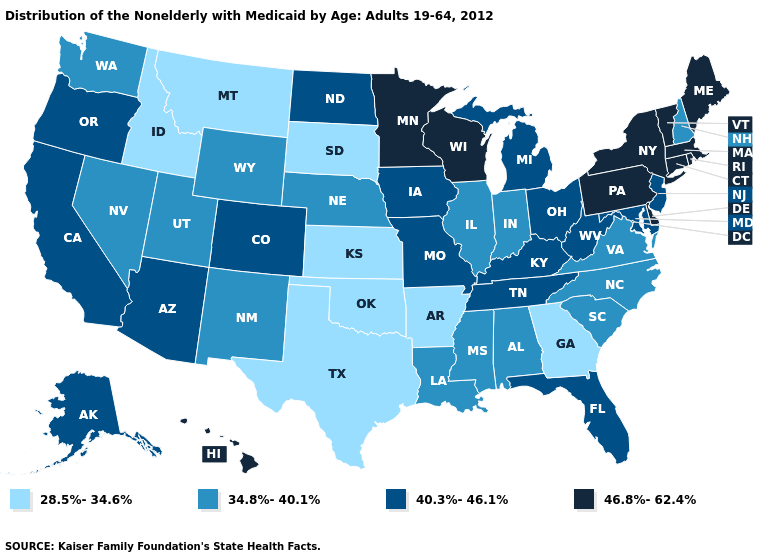How many symbols are there in the legend?
Answer briefly. 4. What is the value of Arkansas?
Write a very short answer. 28.5%-34.6%. What is the highest value in states that border Indiana?
Answer briefly. 40.3%-46.1%. Name the states that have a value in the range 34.8%-40.1%?
Give a very brief answer. Alabama, Illinois, Indiana, Louisiana, Mississippi, Nebraska, Nevada, New Hampshire, New Mexico, North Carolina, South Carolina, Utah, Virginia, Washington, Wyoming. Name the states that have a value in the range 40.3%-46.1%?
Be succinct. Alaska, Arizona, California, Colorado, Florida, Iowa, Kentucky, Maryland, Michigan, Missouri, New Jersey, North Dakota, Ohio, Oregon, Tennessee, West Virginia. What is the value of Maryland?
Concise answer only. 40.3%-46.1%. Name the states that have a value in the range 46.8%-62.4%?
Quick response, please. Connecticut, Delaware, Hawaii, Maine, Massachusetts, Minnesota, New York, Pennsylvania, Rhode Island, Vermont, Wisconsin. Does the first symbol in the legend represent the smallest category?
Give a very brief answer. Yes. Which states have the highest value in the USA?
Answer briefly. Connecticut, Delaware, Hawaii, Maine, Massachusetts, Minnesota, New York, Pennsylvania, Rhode Island, Vermont, Wisconsin. What is the highest value in states that border West Virginia?
Short answer required. 46.8%-62.4%. Name the states that have a value in the range 28.5%-34.6%?
Answer briefly. Arkansas, Georgia, Idaho, Kansas, Montana, Oklahoma, South Dakota, Texas. Does New Hampshire have the highest value in the Northeast?
Give a very brief answer. No. What is the lowest value in the MidWest?
Give a very brief answer. 28.5%-34.6%. Among the states that border Kentucky , which have the lowest value?
Concise answer only. Illinois, Indiana, Virginia. What is the value of Michigan?
Answer briefly. 40.3%-46.1%. 